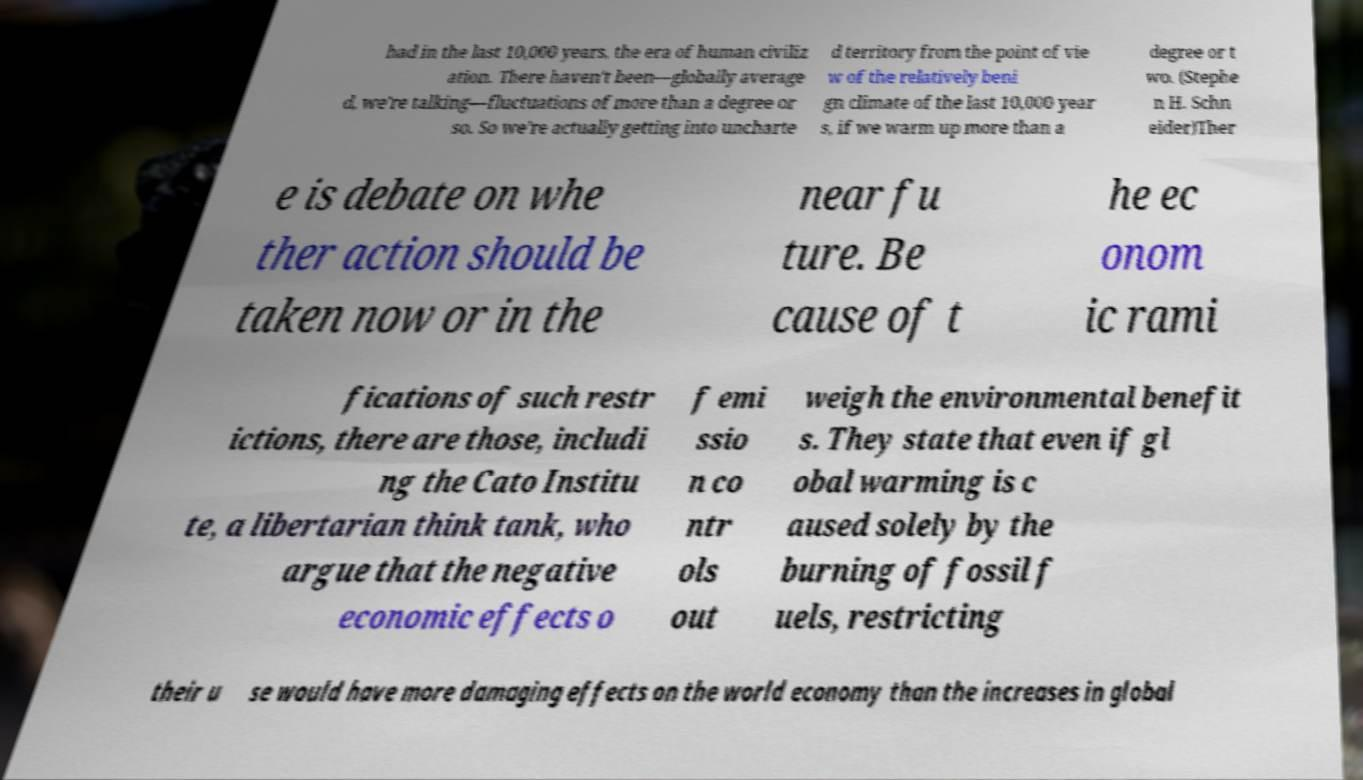Please identify and transcribe the text found in this image. had in the last 10,000 years, the era of human civiliz ation. There haven't been—globally average d, we're talking—fluctuations of more than a degree or so. So we're actually getting into uncharte d territory from the point of vie w of the relatively beni gn climate of the last 10,000 year s, if we warm up more than a degree or t wo. (Stephe n H. Schn eider)Ther e is debate on whe ther action should be taken now or in the near fu ture. Be cause of t he ec onom ic rami fications of such restr ictions, there are those, includi ng the Cato Institu te, a libertarian think tank, who argue that the negative economic effects o f emi ssio n co ntr ols out weigh the environmental benefit s. They state that even if gl obal warming is c aused solely by the burning of fossil f uels, restricting their u se would have more damaging effects on the world economy than the increases in global 